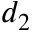Convert formula to latex. <formula><loc_0><loc_0><loc_500><loc_500>d _ { 2 }</formula> 